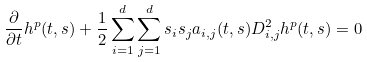Convert formula to latex. <formula><loc_0><loc_0><loc_500><loc_500>\frac { \partial } { \partial t } h ^ { p } ( t , s ) + \frac { 1 } { 2 } \sum _ { i = 1 } ^ { d } \sum _ { j = 1 } ^ { d } s _ { i } s _ { j } a _ { i , j } ( t , s ) D _ { i , j } ^ { 2 } h ^ { p } ( t , s ) = 0</formula> 